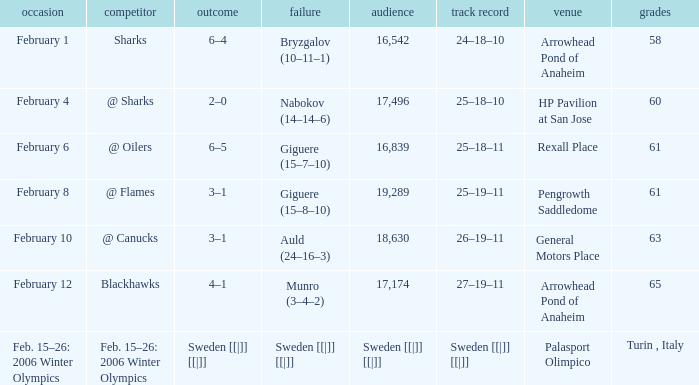What is the record at Palasport Olimpico? Sweden [[|]] [[|]]. 